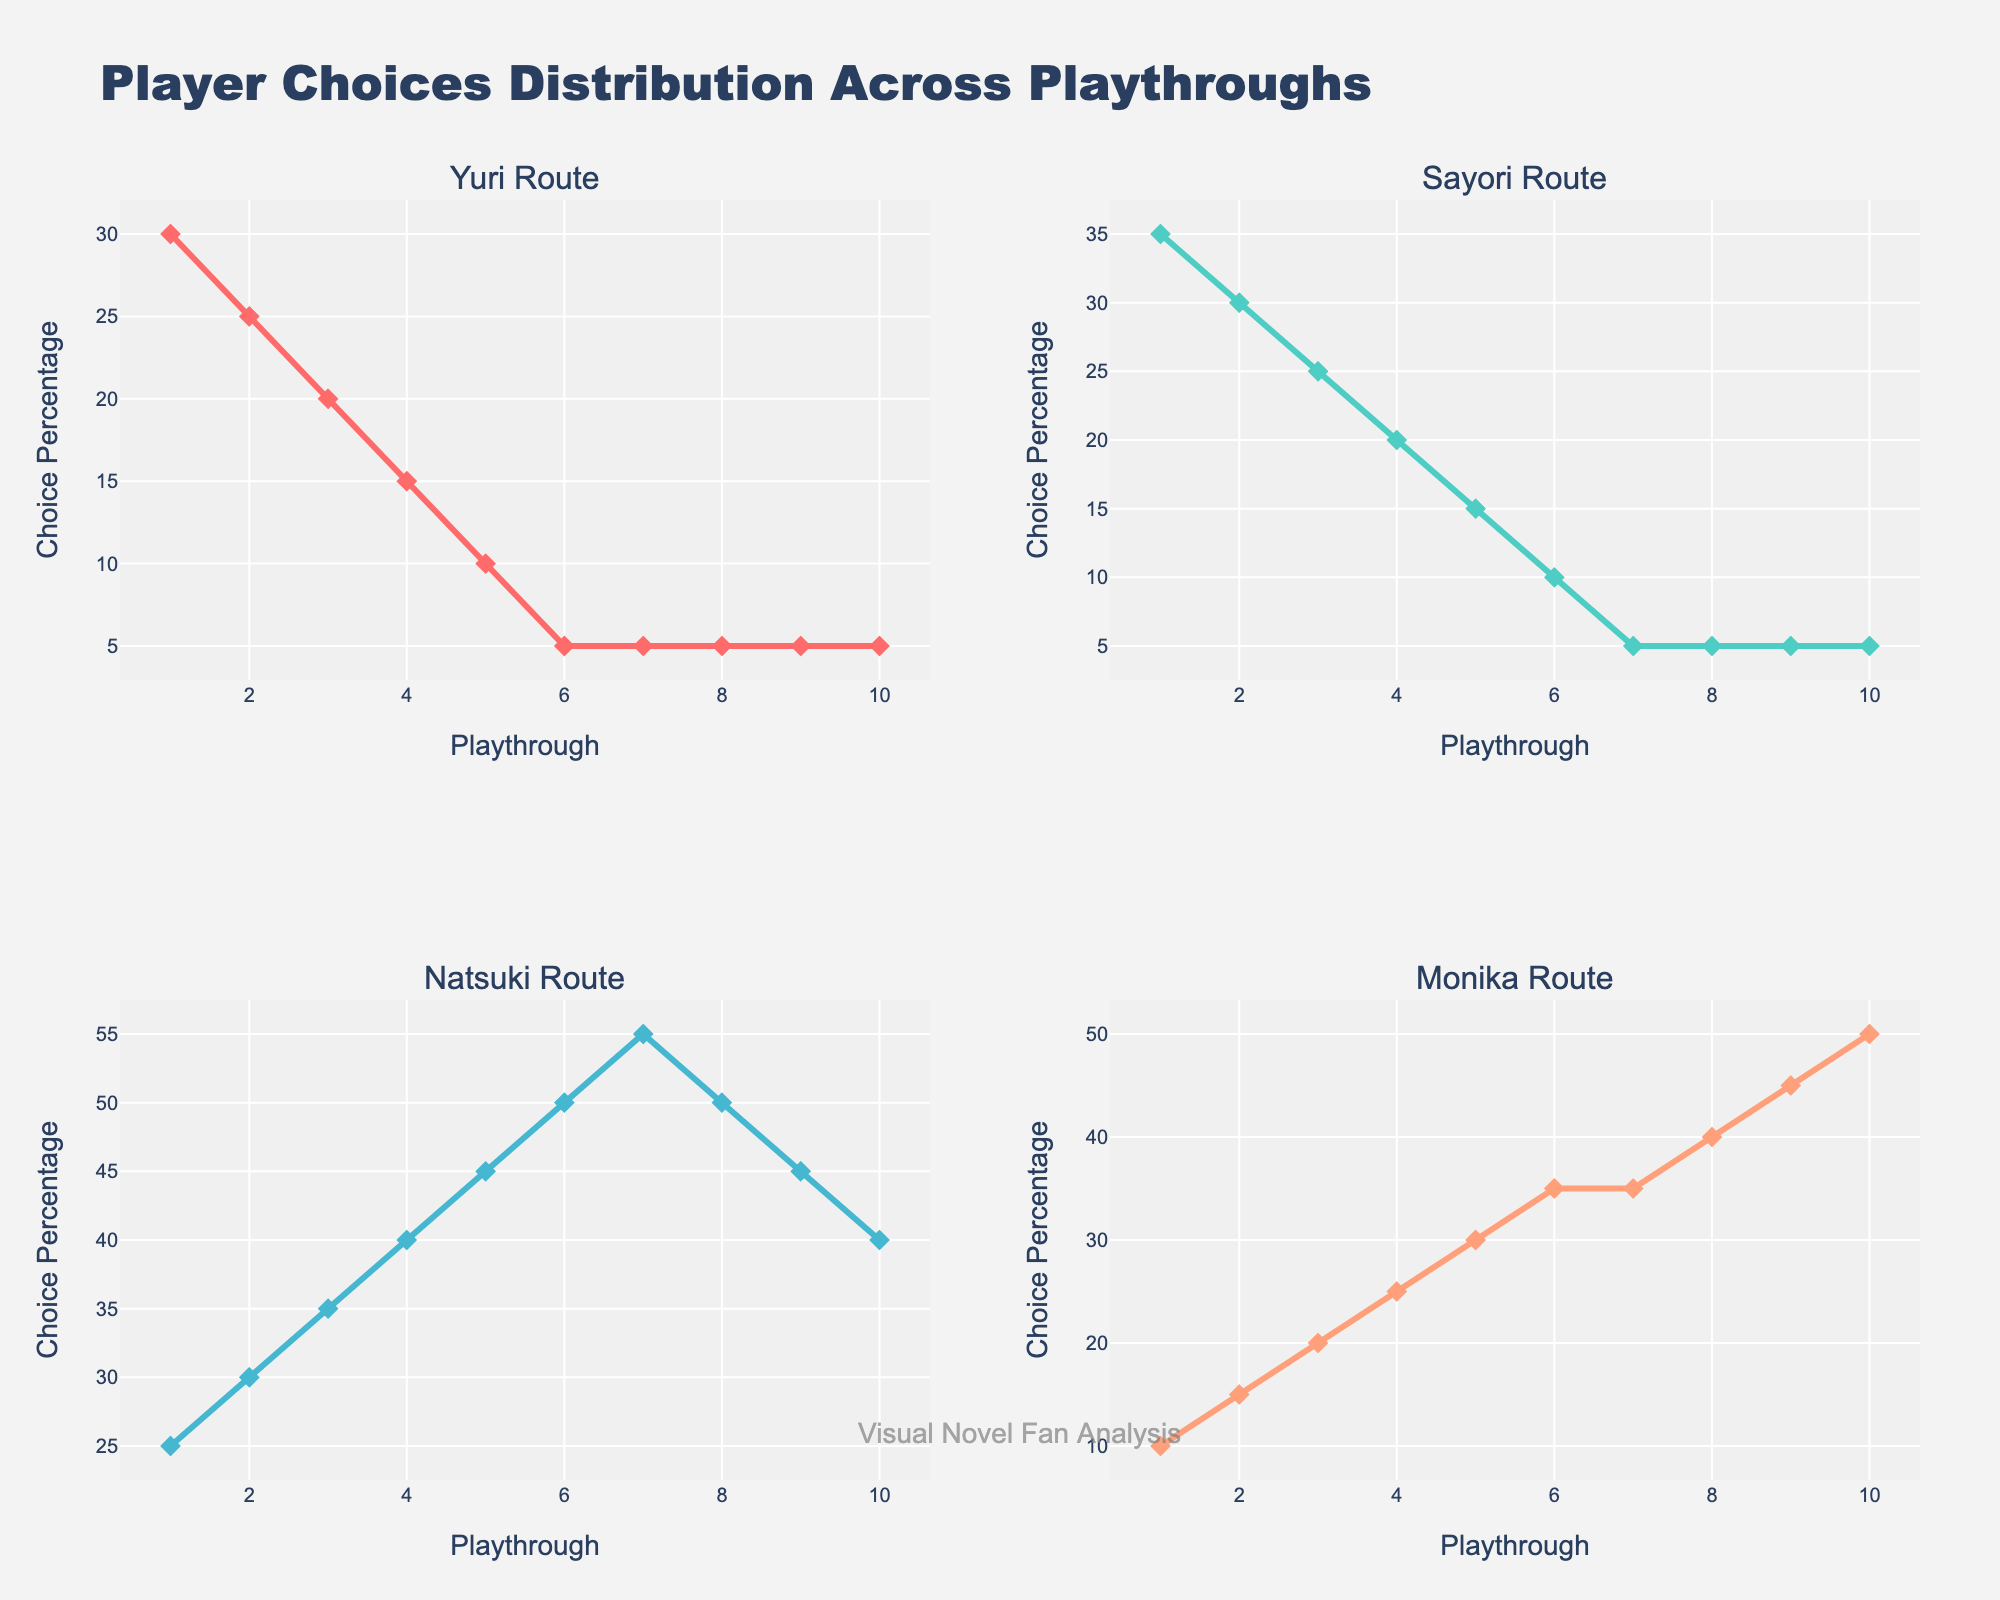What's the title of the plot? The title is displayed at the top center of the figure, which reads "Player Choices Distribution Across Playthroughs".
Answer: Player Choices Distribution Across Playthroughs How does the percentage of players choosing the Yuri route change from playthrough 1 to playthrough 10? Examining the subplot titled "Yuri Route", the percentage decreases from 30% in playthrough 1 to 5% in playthrough 10.
Answer: It decreases from 30% to 5% Which route has the highest choice percentage in playthrough 7? By looking at the subplots for playthrough 7, the Natsuki Route subplot shows the highest percentage at 55%.
Answer: Natsuki Route What is the trend in the Sayori route subplot? Observing the Sayori Route subplot, the trend shows a continuous decline from 35% in playthrough 1 to 5% in playthrough 10.
Answer: Continuous decline At which playthrough does the Monika route first surpass 25%? In the Monika Route subplot, the percentage first exceeds 25% at playthrough 4, where it reaches 25%.
Answer: Playthrough 4 How do the choice percentages for the Natsuki route compare between playthroughs 6 and 8? In the subplot for the Natsuki Route, the percentage is 50% in both playthrough 6 and playthrough 8.
Answer: They are equal Which playthrough shows the highest increase in the Monika route choices compared to the previous playthrough? By comparing each consecutive playthrough in the Monika Route subplot, the largest increase is from playthrough 5 to playthrough 6, where the percentage goes from 30% to 35%, an increase of 5%.
Answer: From playthrough 5 to 6 What can you infer about the player choices for Yuri and Natsuki routes in the last three playthroughs? Observing the last three playthroughs for Yuri and Natsuki routes: Yuri stays constant at 5%, while Natsuki decreases from 50% to 45% to 40%.
Answer: Yuri is constant at 5%; Natsuki decreases What is the combined percentage of choices for Sayori and Monika routes in playthrough 10? Adding the values from the Sayori and Monika Route subplots for playthrough 10: 5% and 50%, which sums to 55%.
Answer: 55% How does the variation in choice percentages over the playthroughs compare across all routes? Analyzing each subplot: Yuri and Sayori show a steady decline, Natsuki shows an increase then stabilizes, and Monika shows a consistent increase.
Answer: Yuri & Sayori decline; Natsuki increases & stabilizes; Monika increases 